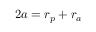Convert formula to latex. <formula><loc_0><loc_0><loc_500><loc_500>2 a = r _ { p } + r _ { a }</formula> 